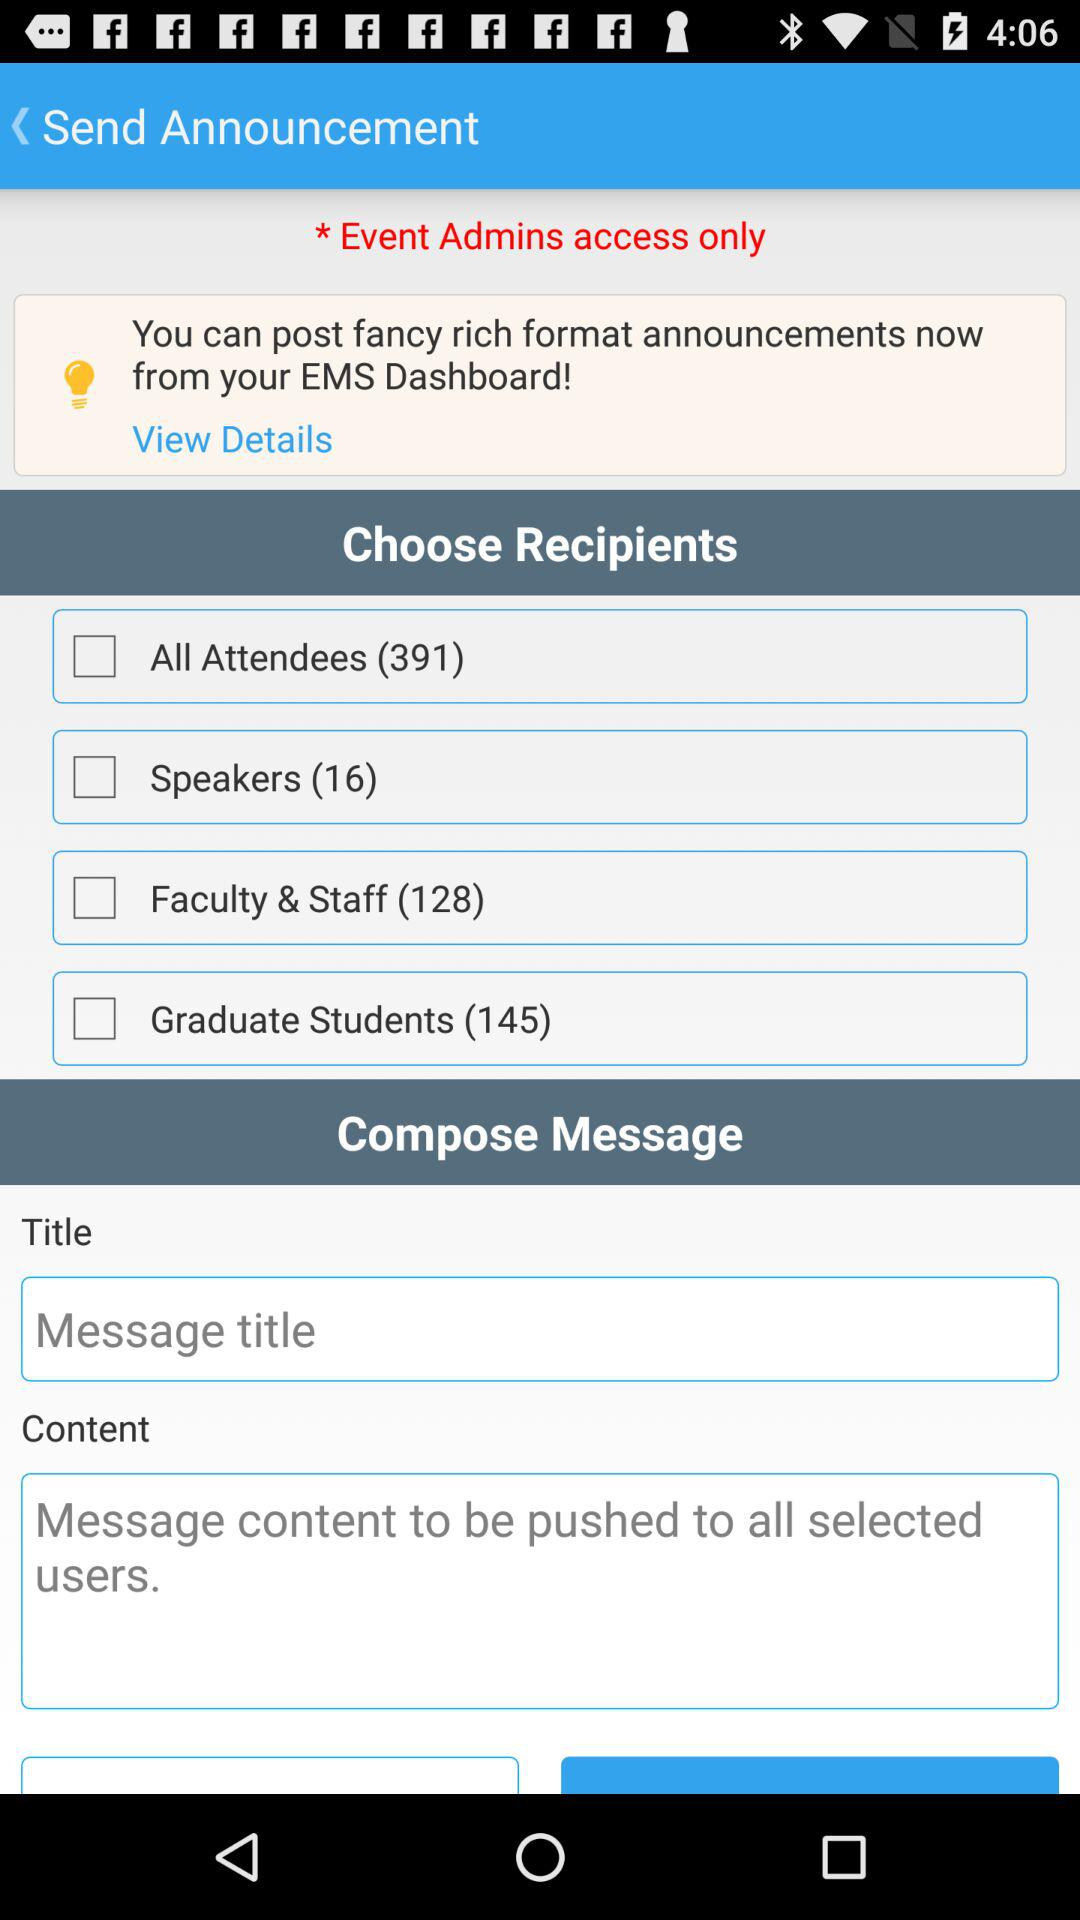How many graduate students are there? There are 145 graduate students. 